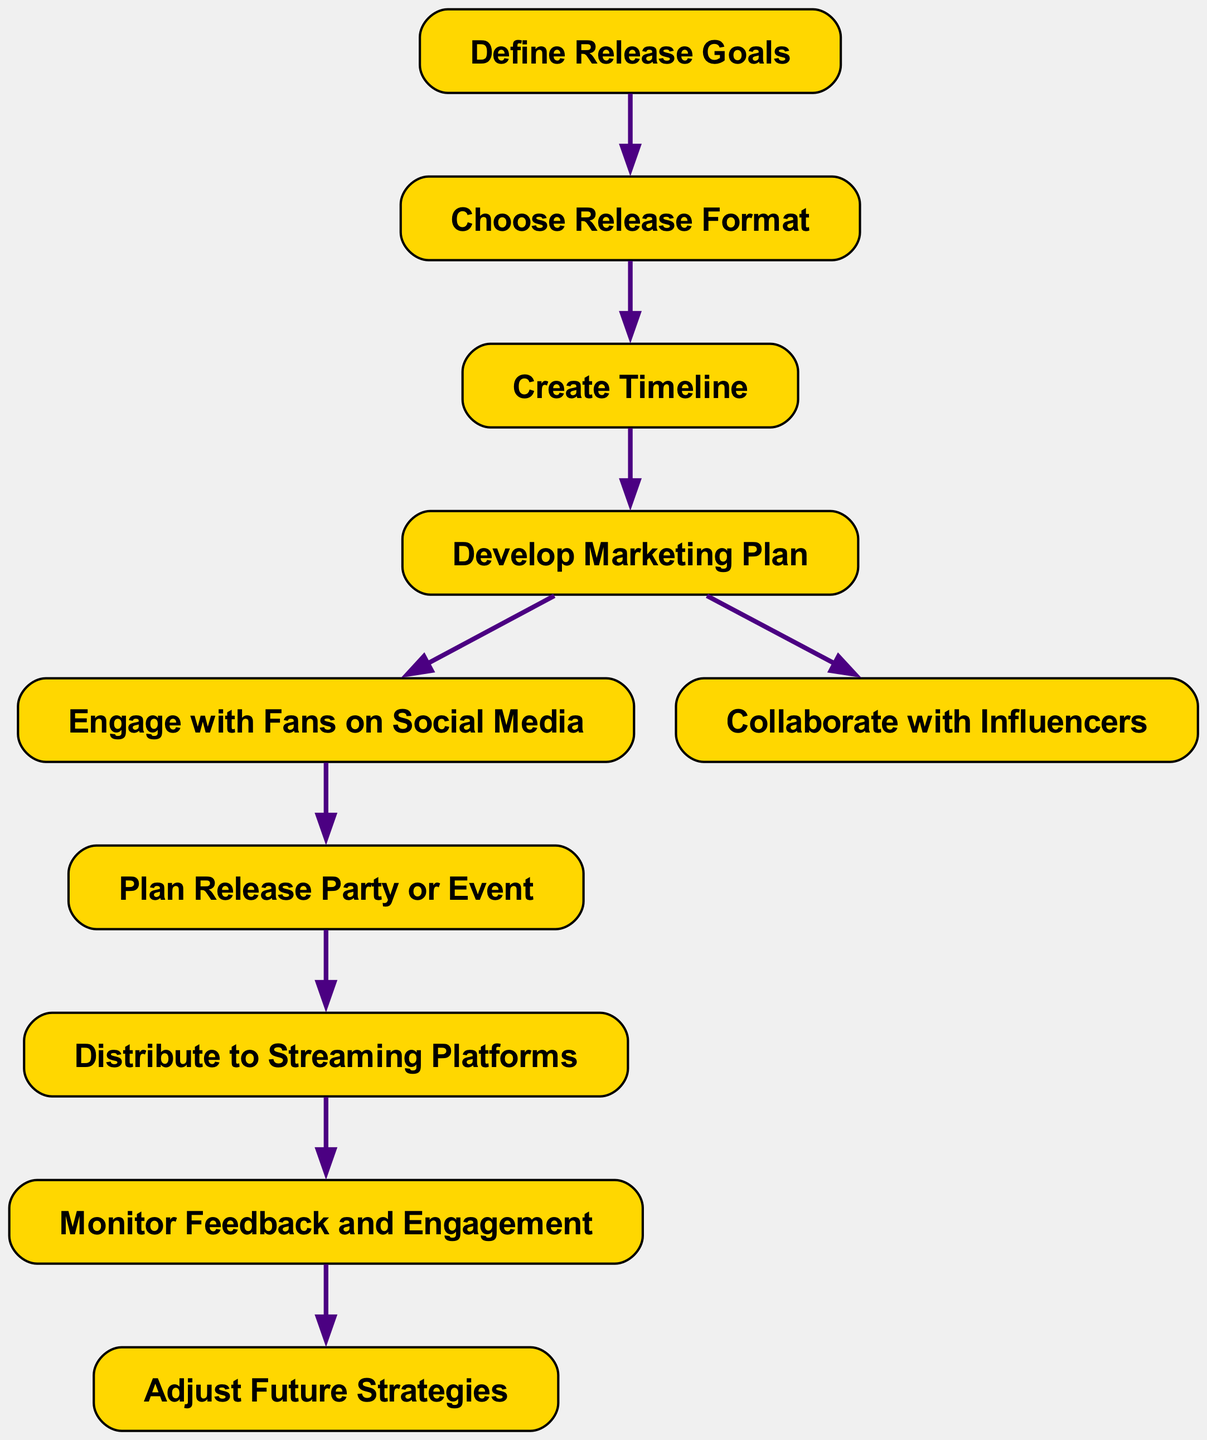What is the first step in the music release strategy? The first node in the flow chart is labeled "Define Release Goals," indicating that this is the initial step in the strategy.
Answer: Define Release Goals How many nodes are present in the diagram? By counting the individual nodes listed, there are a total of ten nodes represented in the flow chart.
Answer: 10 What follows after "Develop Marketing Plan"? The flow from "Develop Marketing Plan" leads to two options: "Engage with Fans on Social Media" and "Collaborate with Influencers." Hence, the next step can be either one of those two.
Answer: Engage with Fans on Social Media / Collaborate with Influencers What is the final node in the flow chart? The flow ends at the node labeled "Adjust Future Strategies," which is the last step in the music release strategy.
Answer: Adjust Future Strategies Which two steps have a direct connection to "Marketing Plan"? The node "Develop Marketing Plan" connects directly to "Engage with Fans on Social Media" and "Collaborate with Influencers," meaning these are the two subsequent steps related to marketing.
Answer: Engage with Fans on Social Media, Collaborate with Influencers What action is taken after distributing to streaming platforms? After the node "Distribute to Streaming Platforms," the next step is "Monitor Feedback and Engagement," indicating that monitoring follows distribution.
Answer: Monitor Feedback and Engagement Which node has an incoming edge from "Plan Release Party or Event"? The node "Distribute to Streaming Platforms" receives its input from "Plan Release Party or Event," implying that planning the party ties into the distribution phase.
Answer: Distribute to Streaming Platforms What action is suggested before creating a timeline? "Choose Release Format" comes after defining release goals and is suggested to be completed before creating a timeline, indicating it's a prerequisite for the timeline step.
Answer: Choose Release Format 